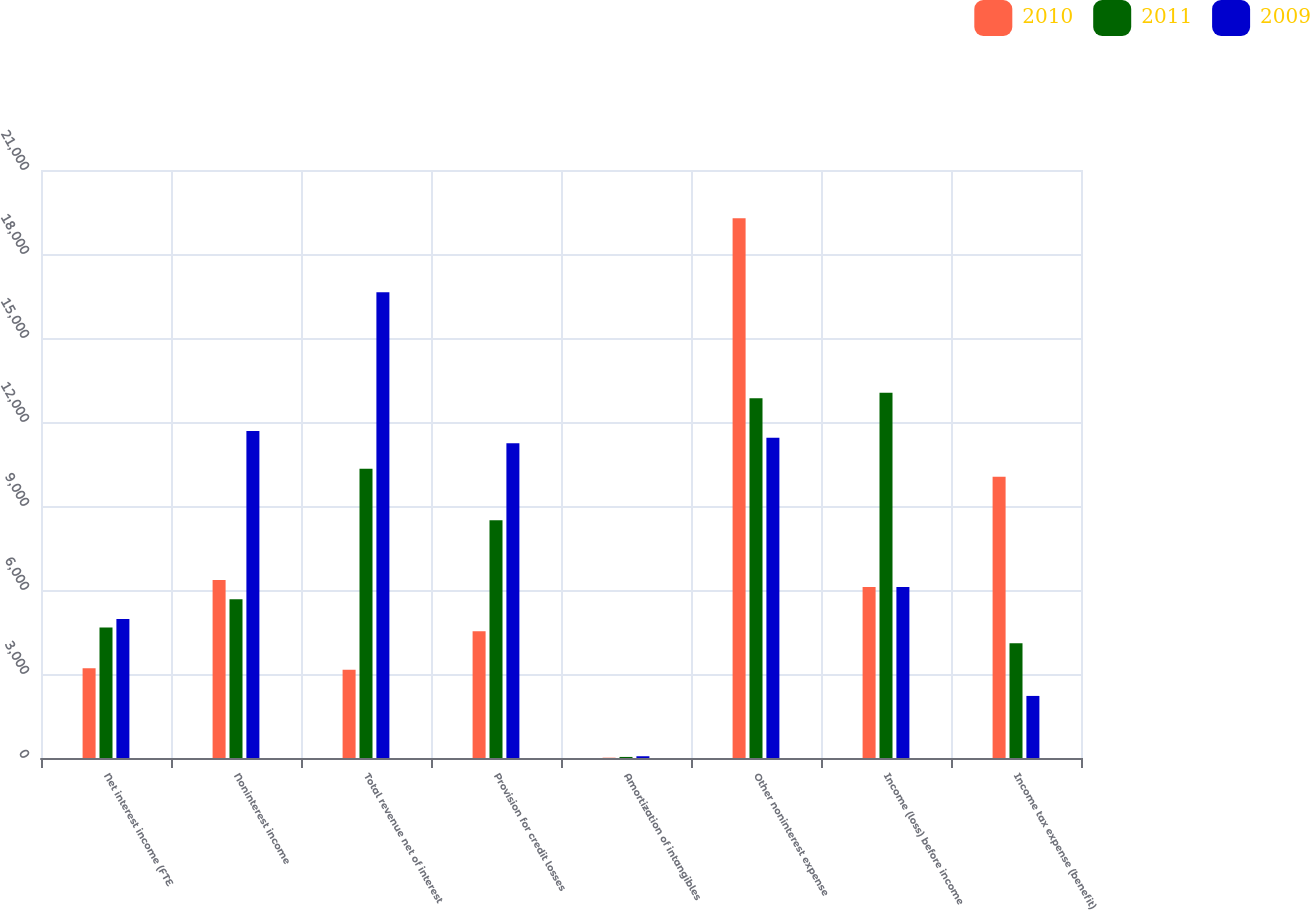Convert chart. <chart><loc_0><loc_0><loc_500><loc_500><stacked_bar_chart><ecel><fcel>Net interest income (FTE<fcel>Noninterest income<fcel>Total revenue net of interest<fcel>Provision for credit losses<fcel>Amortization of intangibles<fcel>Other noninterest expense<fcel>Income (loss) before income<fcel>Income tax expense (benefit)<nl><fcel>2010<fcel>3207<fcel>6361<fcel>3154<fcel>4524<fcel>11<fcel>19279<fcel>6106<fcel>10042<nl><fcel>2011<fcel>4662<fcel>5667<fcel>10329<fcel>8490<fcel>38<fcel>12848<fcel>13047<fcel>4100<nl><fcel>2009<fcel>4961<fcel>11677<fcel>16638<fcel>11244<fcel>63<fcel>11437<fcel>6106<fcel>2217<nl></chart> 